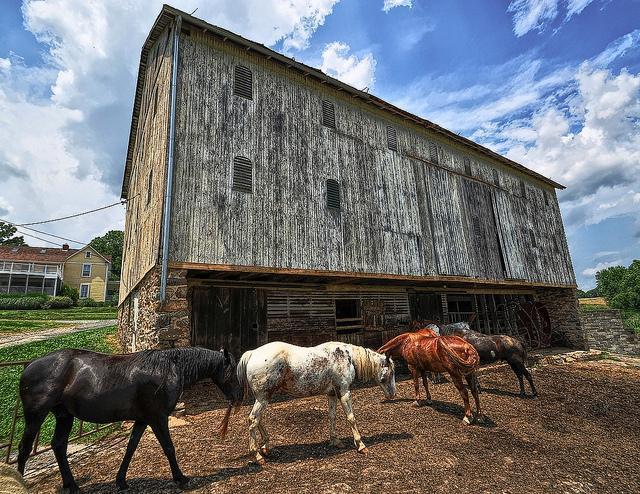How many houses are there?
Give a very brief answer. 1. How many horses are there?
Give a very brief answer. 4. How many horses are in the picture?
Give a very brief answer. 4. How many people are wearing glasses?
Give a very brief answer. 0. 